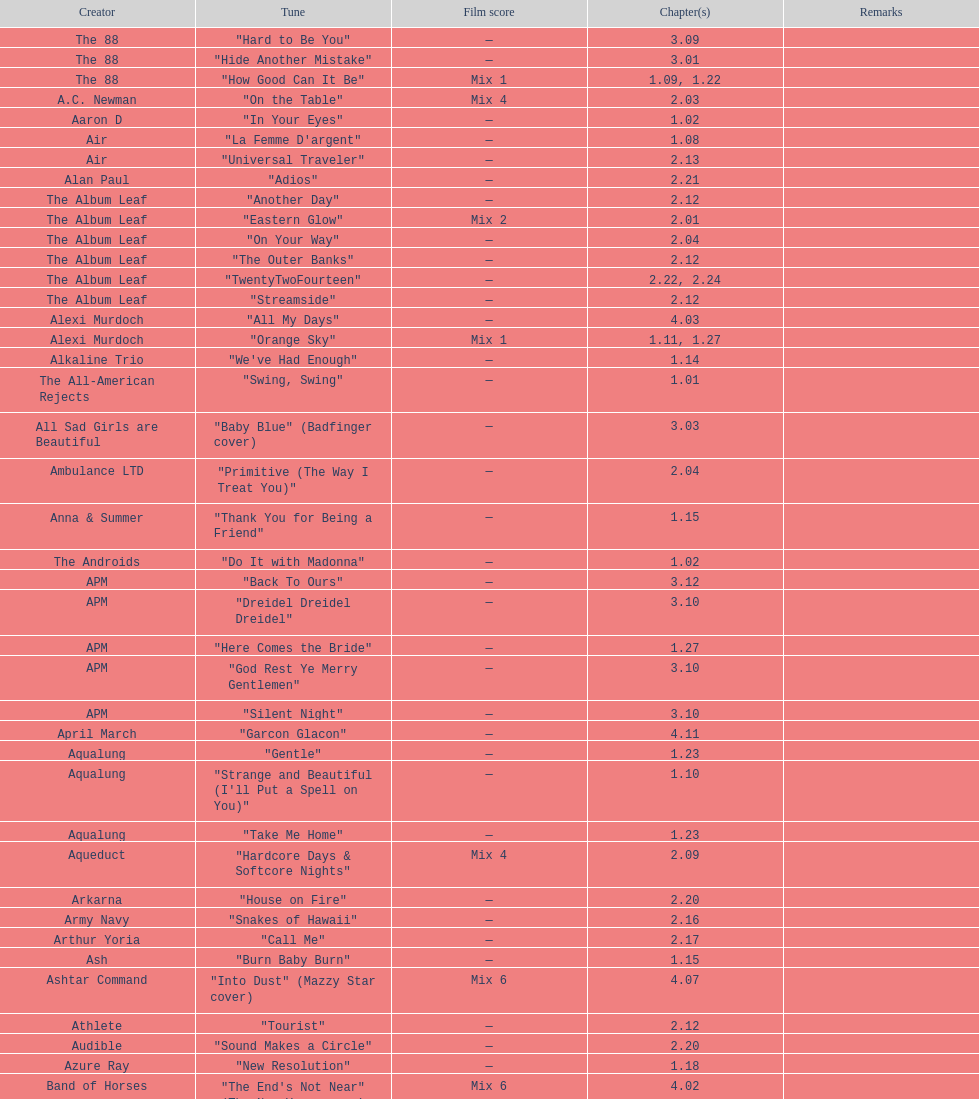What artist has more music appear in the show, daft punk or franz ferdinand? Franz Ferdinand. 